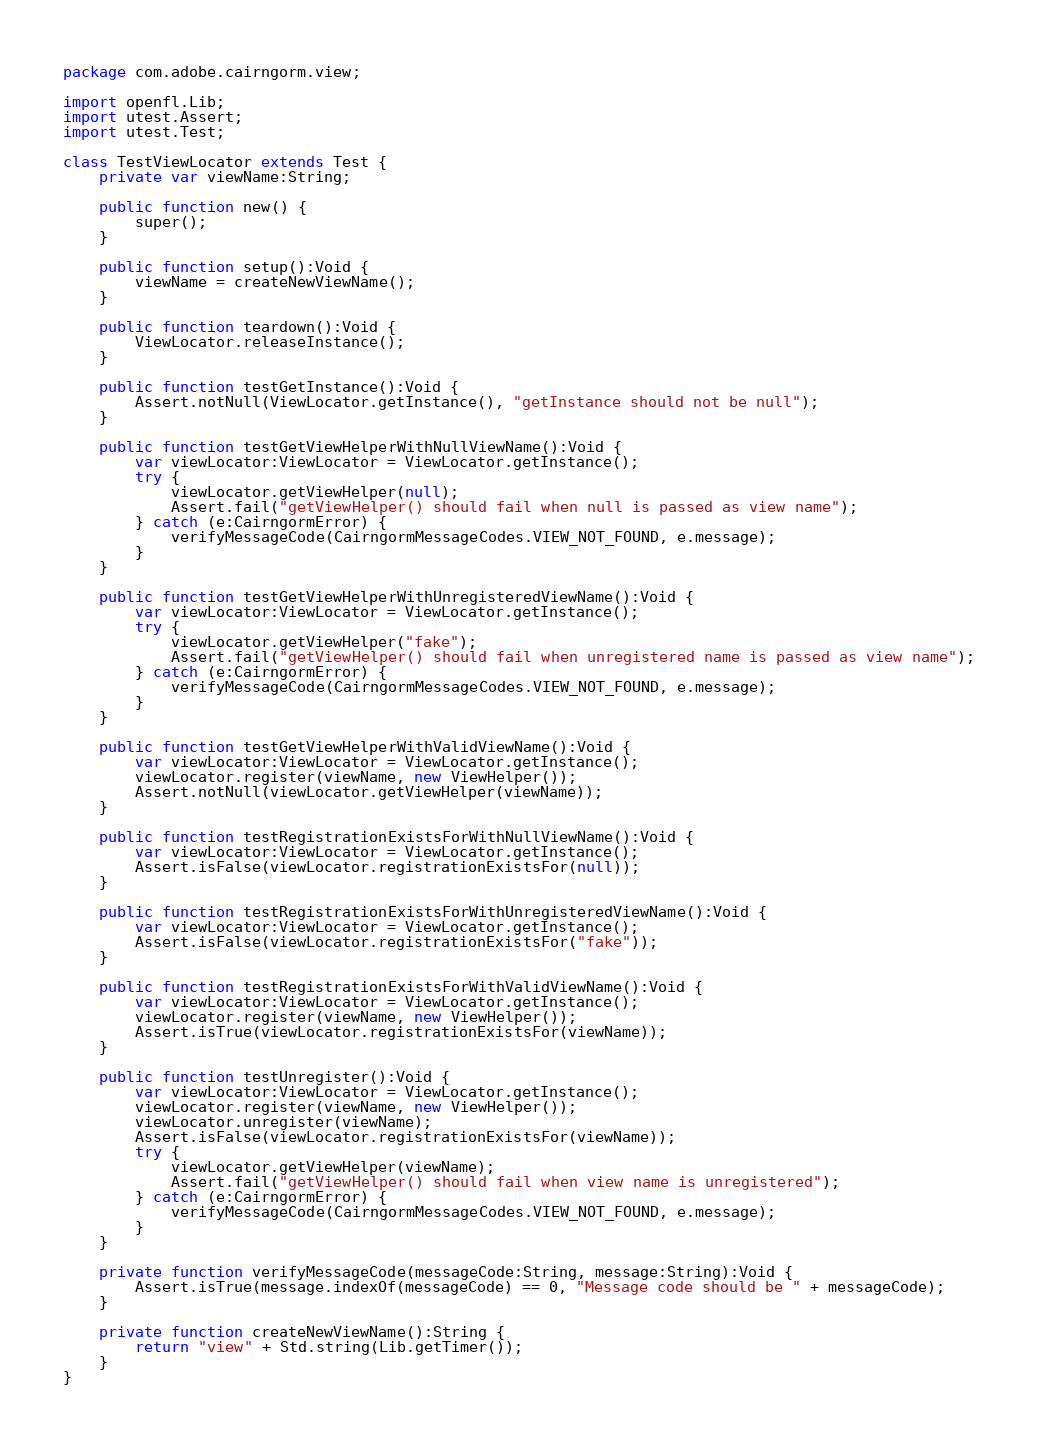Convert code to text. <code><loc_0><loc_0><loc_500><loc_500><_Haxe_>package com.adobe.cairngorm.view;

import openfl.Lib;
import utest.Assert;
import utest.Test;

class TestViewLocator extends Test {
	private var viewName:String;

	public function new() {
		super();
	}

	public function setup():Void {
		viewName = createNewViewName();
	}

	public function teardown():Void {
		ViewLocator.releaseInstance();
	}

	public function testGetInstance():Void {
		Assert.notNull(ViewLocator.getInstance(), "getInstance should not be null");
	}

	public function testGetViewHelperWithNullViewName():Void {
		var viewLocator:ViewLocator = ViewLocator.getInstance();
		try {
			viewLocator.getViewHelper(null);
			Assert.fail("getViewHelper() should fail when null is passed as view name");
		} catch (e:CairngormError) {
			verifyMessageCode(CairngormMessageCodes.VIEW_NOT_FOUND, e.message);
		}
	}

	public function testGetViewHelperWithUnregisteredViewName():Void {
		var viewLocator:ViewLocator = ViewLocator.getInstance();
		try {
			viewLocator.getViewHelper("fake");
			Assert.fail("getViewHelper() should fail when unregistered name is passed as view name");
		} catch (e:CairngormError) {
			verifyMessageCode(CairngormMessageCodes.VIEW_NOT_FOUND, e.message);
		}
	}

	public function testGetViewHelperWithValidViewName():Void {
		var viewLocator:ViewLocator = ViewLocator.getInstance();
		viewLocator.register(viewName, new ViewHelper());
		Assert.notNull(viewLocator.getViewHelper(viewName));
	}

	public function testRegistrationExistsForWithNullViewName():Void {
		var viewLocator:ViewLocator = ViewLocator.getInstance();
		Assert.isFalse(viewLocator.registrationExistsFor(null));
	}

	public function testRegistrationExistsForWithUnregisteredViewName():Void {
		var viewLocator:ViewLocator = ViewLocator.getInstance();
		Assert.isFalse(viewLocator.registrationExistsFor("fake"));
	}

	public function testRegistrationExistsForWithValidViewName():Void {
		var viewLocator:ViewLocator = ViewLocator.getInstance();
		viewLocator.register(viewName, new ViewHelper());
		Assert.isTrue(viewLocator.registrationExistsFor(viewName));
	}

	public function testUnregister():Void {
		var viewLocator:ViewLocator = ViewLocator.getInstance();
		viewLocator.register(viewName, new ViewHelper());
		viewLocator.unregister(viewName);
		Assert.isFalse(viewLocator.registrationExistsFor(viewName));
		try {
			viewLocator.getViewHelper(viewName);
			Assert.fail("getViewHelper() should fail when view name is unregistered");
		} catch (e:CairngormError) {
			verifyMessageCode(CairngormMessageCodes.VIEW_NOT_FOUND, e.message);
		}
	}

	private function verifyMessageCode(messageCode:String, message:String):Void {
		Assert.isTrue(message.indexOf(messageCode) == 0, "Message code should be " + messageCode);
	}

	private function createNewViewName():String {
		return "view" + Std.string(Lib.getTimer());
	}
}
</code> 